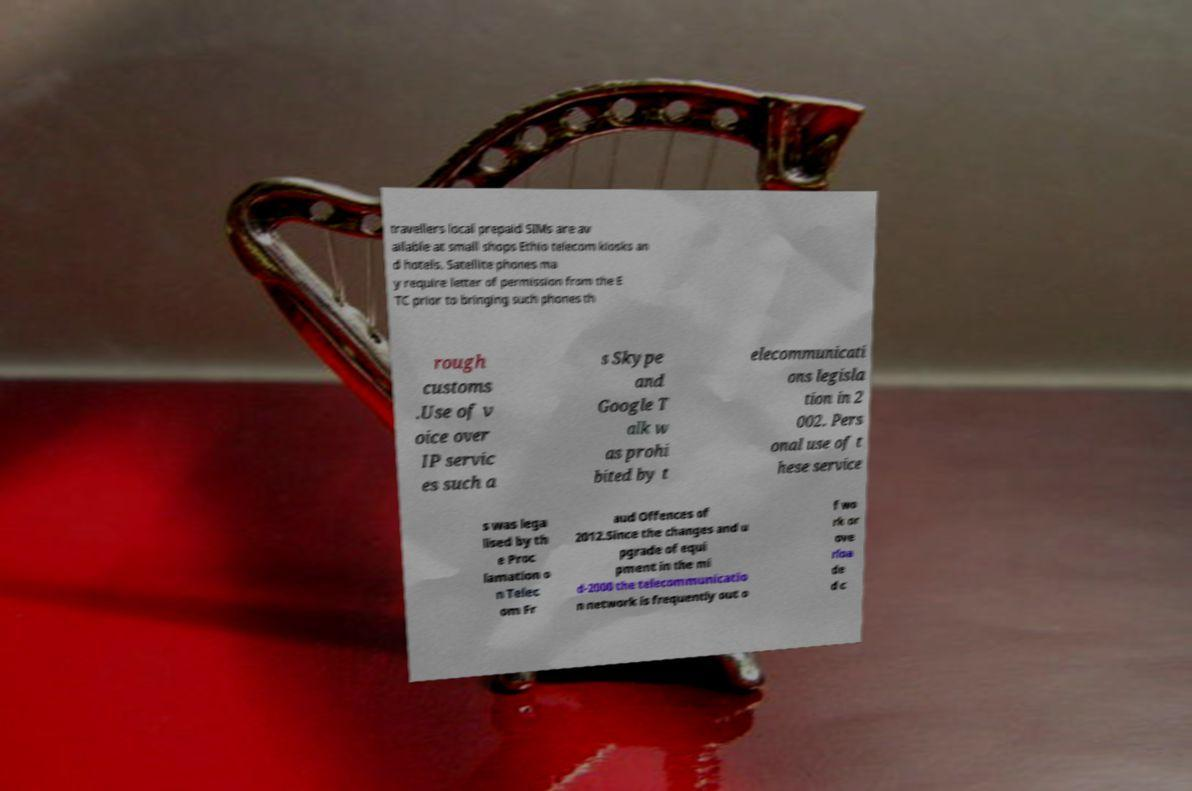Please identify and transcribe the text found in this image. travellers local prepaid SIMs are av ailable at small shops Ethio telecom kiosks an d hotels. Satellite phones ma y require letter of permission from the E TC prior to bringing such phones th rough customs .Use of v oice over IP servic es such a s Skype and Google T alk w as prohi bited by t elecommunicati ons legisla tion in 2 002. Pers onal use of t hese service s was lega lised by th e Proc lamation o n Telec om Fr aud Offences of 2012.Since the changes and u pgrade of equi pment in the mi d-2000 the telecommunicatio n network is frequently out o f wo rk or ove rloa de d c 